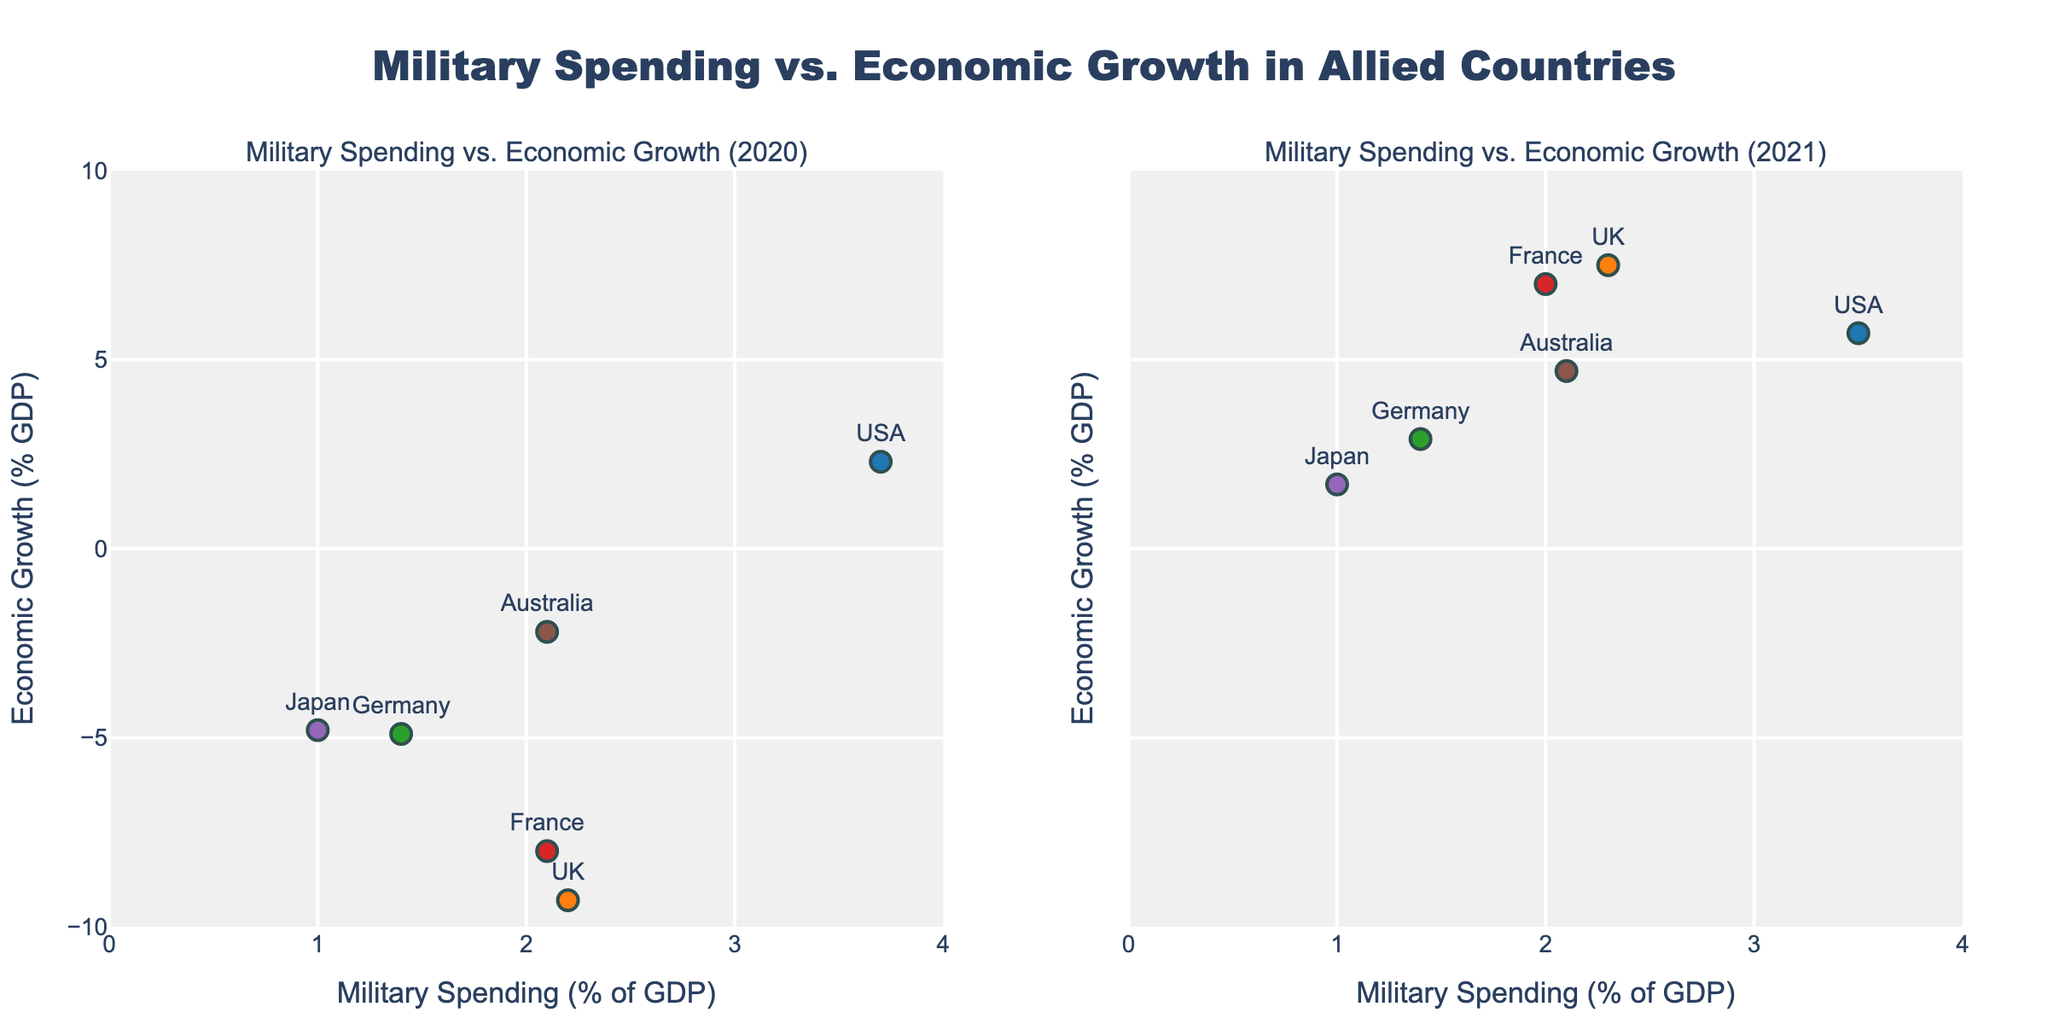Which country had the highest economic growth in 2021? To find the country with the highest economic growth in 2021, look at the y-axis values on the right subplot for 2021. Observe the position of each country's marker relative to the y-axis. The country with the highest position is the one with the highest economic growth.
Answer: UK How did Germany's economic growth change from 2020 to 2021? Compare the positions of Germany's markers on the y-axis between the two subplots for 2020 and 2021. The y-axis value for Germany in 2020 is lower compared to 2021, indicating a positive change in economic growth.
Answer: Increased Which year had a higher average economic growth for all countries combined? To determine this, calculate the average economic growth for all countries for each year by adding the economic growth values and dividing by the number of countries. Compare the averages for 2020 and 2021.
Answer: 2021 Which country had a consistent military spending as a percentage of GDP from 2020 to 2021? Look for a country whose markers for military spending on the x-axis did not change between 2020 and 2021. Check the alignment of the markers horizontally in both subplots.
Answer: Japan Is there a correlation between military spending and economic growth in the data? To identify any correlation, observe the pattern or trend in the scatter plot between the x-axis (military spending) and the y-axis (economic growth) for both years. If there's a trend line (positive or negative), it suggests a correlation.
Answer: No clear correlation Which country had the largest increase in economic growth from 2020 to 2021? Calculate the difference in the y-axis values (economic growth) for each country between 2020 and 2021. Identify the country with the largest positive difference.
Answer: France What color represents Australia in the plots? Refer to the legend in the subplots or the description in the data provided to identify the color assigned to Australia in the scatter plot.
Answer: Brown How does the title describe the plots? Read the title at the top of the figure to understand how it describes the data represented in the plots.
Answer: Military Spending vs. Economic Growth in Allied Countries Compared to other countries, did the USA have a higher or lower military spending as a percentage of GDP? Look at the x-axis positions of the USA markers in both subplots and compare them with the positions of other countries' markers to determine if the USA's military spending is higher or lower.
Answer: Higher In which year did France have a higher economic growth rate? Compare the y-axis positions of France's markers between the 2020 and 2021 subplots. The position in 2021 is higher than in 2020, indicating a higher economic growth rate.
Answer: 2021 